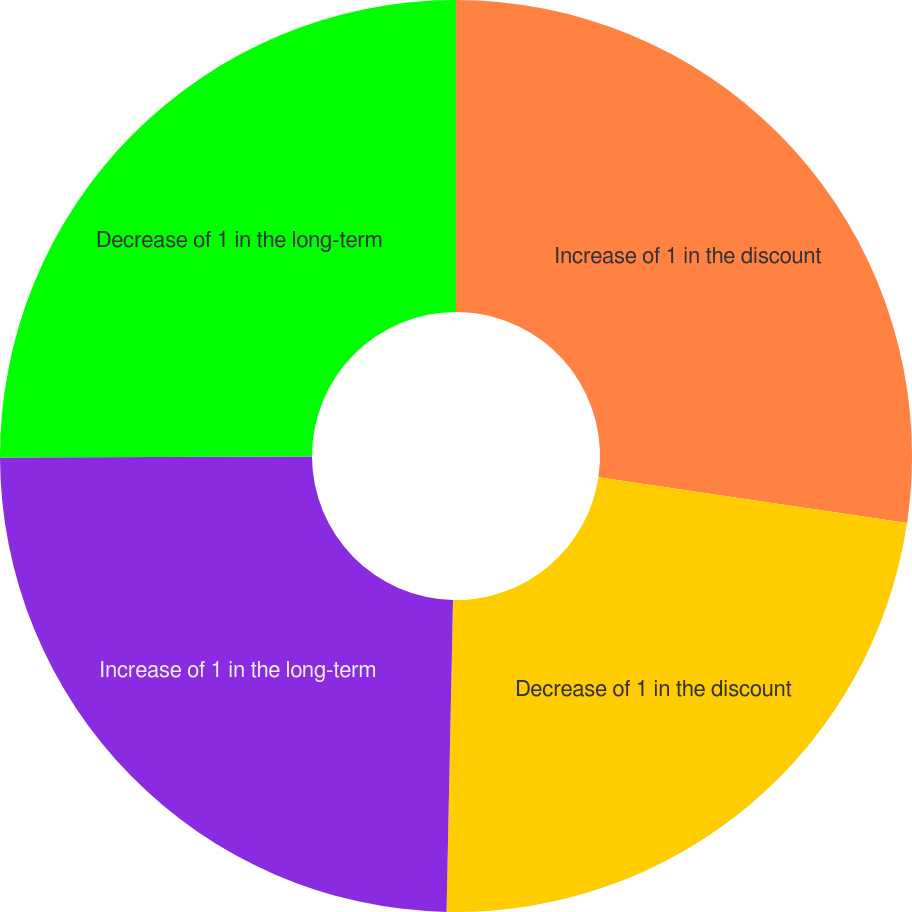Convert chart. <chart><loc_0><loc_0><loc_500><loc_500><pie_chart><fcel>Increase of 1 in the discount<fcel>Decrease of 1 in the discount<fcel>Increase of 1 in the long-term<fcel>Decrease of 1 in the long-term<nl><fcel>27.35%<fcel>22.98%<fcel>24.62%<fcel>25.05%<nl></chart> 